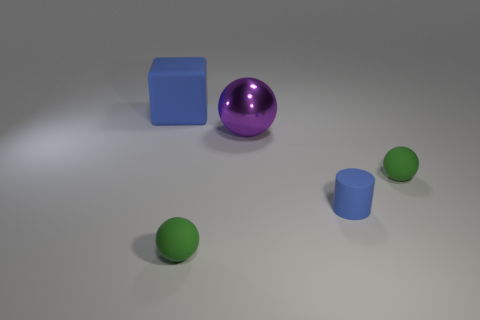What is the color of the large object that is right of the blue object that is behind the small green matte object that is on the right side of the metal thing? purple 